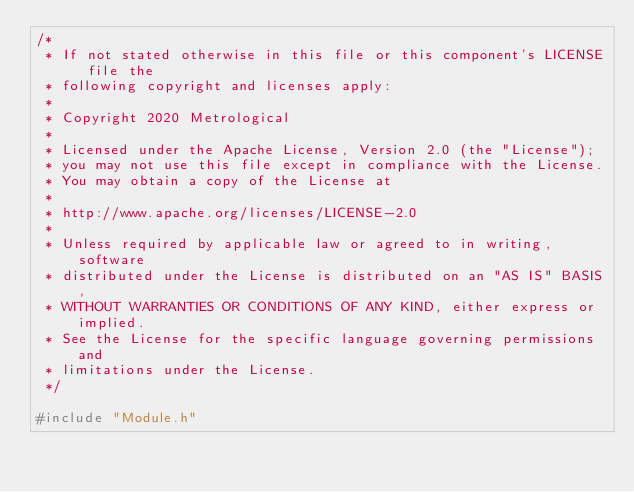<code> <loc_0><loc_0><loc_500><loc_500><_C++_>/*
 * If not stated otherwise in this file or this component's LICENSE file the
 * following copyright and licenses apply:
 *
 * Copyright 2020 Metrological
 *
 * Licensed under the Apache License, Version 2.0 (the "License");
 * you may not use this file except in compliance with the License.
 * You may obtain a copy of the License at
 *
 * http://www.apache.org/licenses/LICENSE-2.0
 *
 * Unless required by applicable law or agreed to in writing, software
 * distributed under the License is distributed on an "AS IS" BASIS,
 * WITHOUT WARRANTIES OR CONDITIONS OF ANY KIND, either express or implied.
 * See the License for the specific language governing permissions and
 * limitations under the License.
 */

#include "Module.h"
</code> 